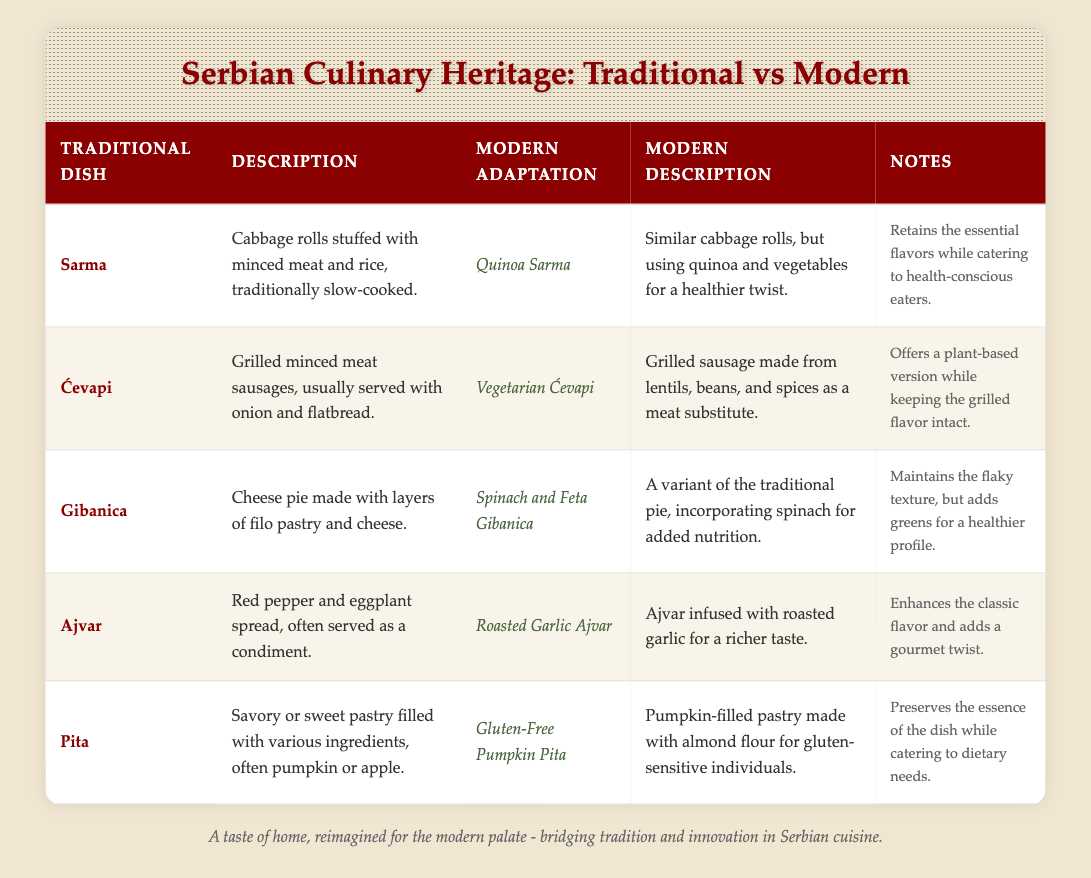What is the traditional Serbian dish that is a cabbage roll? The table lists "Sarma" as the traditional Serbian dish that is specifically described as cabbage rolls stuffed with minced meat and rice.
Answer: Sarma What modern adaptation of Ćevapi is mentioned in the table? The table states that the modern adaptation of Ćevapi is called "Vegetarian Ćevapi," which uses lentils, beans, and spices instead of meat.
Answer: Vegetarian Ćevapi Which dish has a modern adaptation that incorporates spinach? According to the table, "Gibanica" has a modern adaptation that incorporates spinach, which is noted as "Spinach and Feta Gibanica."
Answer: Gibanica Is Ajvar traditionally served as a condiment? The table confirms that Ajvar is described as a red pepper and eggplant spread, often served as a condiment.
Answer: Yes Do all modern adaptations mentioned in the table retain a similar texture to the traditional dishes? Reviewing the notes, it is clear that while the modern adaptations may alter ingredients for health considerations, most, like Gibanica and Sarma, retain the essential flavors or textures associated with the traditional dishes.
Answer: Yes What are the two main ingredients of the traditional dish Sarma? The traditional dish Sarma consists of cabbage rolls stuffed with minced meat and rice as detailed in the table.
Answer: Cabbage and minced meat How does the description of Roasted Garlic Ajvar differ from traditional Ajvar? The table specifies that Roasted Garlic Ajvar is infused with roasted garlic for a richer taste, enhancing the classic flavor of traditional Ajvar described simply as a red pepper and eggplant spread.
Answer: It adds roasted garlic for a richer taste Which modern adaptation caters specifically to gluten-sensitive individuals? The modern adaptation aimed at gluten-sensitive individuals is "Gluten-Free Pumpkin Pita," made with almond flour as specified in the table.
Answer: Gluten-Free Pumpkin Pita How many dishes in the table feature a healthier twist using vegetables? The table lists three dishes that feature a healthier twist using vegetables: Quinoa Sarma, Spinach and Feta Gibanica, and Vegetarian Ćevapi, indicating a focus on health-conscious adaptations.
Answer: Three dishes What is the role of the notes section in the table? The notes section provides additional context on how the modern adaptations maintain traditional flavors, offer healthier options, or cater to dietary needs, thus emphasizing the connection between traditional and modern dishes.
Answer: To provide additional context on adaptations What similarities exist between the modern adaptation of Sarma and traditional Sarma? The modern adaptation of Sarma retains essential flavors from the traditional dish while using quinoa and vegetables for a healthier approach, indicating a preserved essence despite ingredient changes.
Answer: Both retain essential flavors 